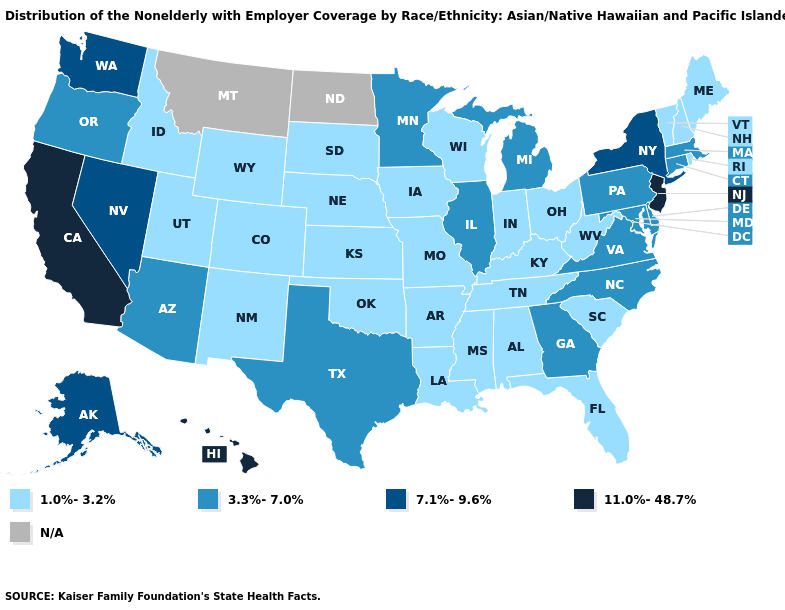What is the value of Connecticut?
Short answer required. 3.3%-7.0%. What is the lowest value in the Northeast?
Quick response, please. 1.0%-3.2%. What is the value of Hawaii?
Answer briefly. 11.0%-48.7%. Does the map have missing data?
Short answer required. Yes. Among the states that border New Mexico , which have the highest value?
Answer briefly. Arizona, Texas. What is the value of South Carolina?
Concise answer only. 1.0%-3.2%. Which states have the lowest value in the MidWest?
Keep it brief. Indiana, Iowa, Kansas, Missouri, Nebraska, Ohio, South Dakota, Wisconsin. Among the states that border Pennsylvania , which have the highest value?
Quick response, please. New Jersey. Does Washington have the lowest value in the USA?
Concise answer only. No. What is the value of Wyoming?
Short answer required. 1.0%-3.2%. Name the states that have a value in the range 1.0%-3.2%?
Concise answer only. Alabama, Arkansas, Colorado, Florida, Idaho, Indiana, Iowa, Kansas, Kentucky, Louisiana, Maine, Mississippi, Missouri, Nebraska, New Hampshire, New Mexico, Ohio, Oklahoma, Rhode Island, South Carolina, South Dakota, Tennessee, Utah, Vermont, West Virginia, Wisconsin, Wyoming. Name the states that have a value in the range 11.0%-48.7%?
Be succinct. California, Hawaii, New Jersey. Does the first symbol in the legend represent the smallest category?
Be succinct. Yes. Name the states that have a value in the range 7.1%-9.6%?
Answer briefly. Alaska, Nevada, New York, Washington. What is the highest value in the USA?
Be succinct. 11.0%-48.7%. 